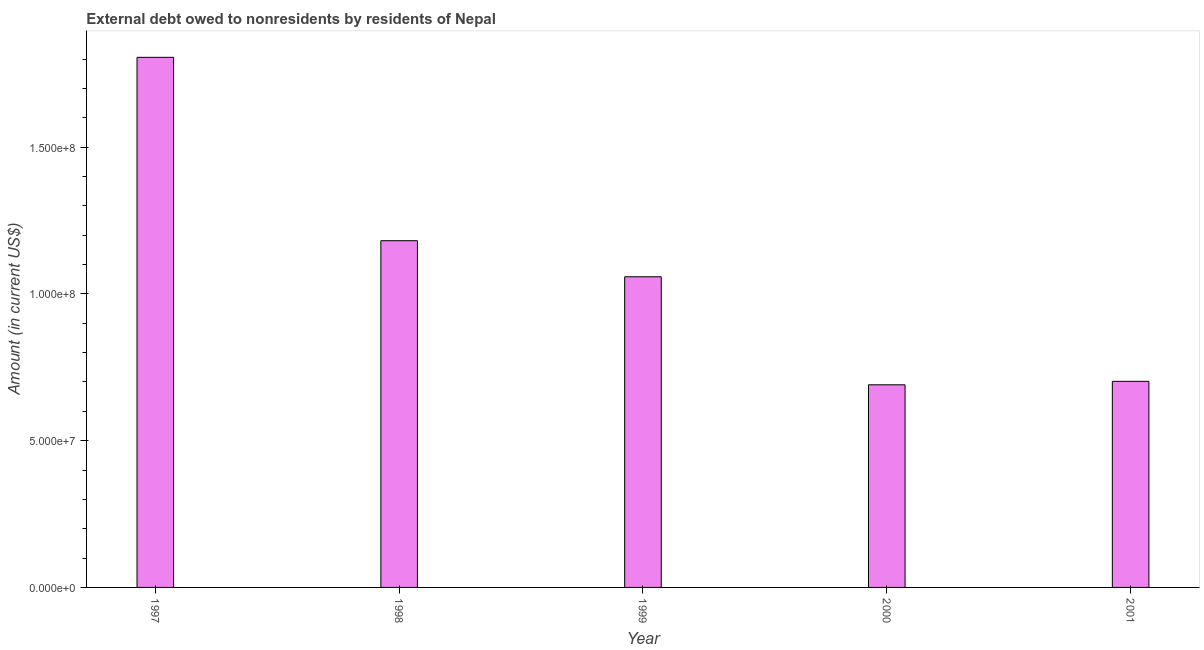What is the title of the graph?
Offer a terse response. External debt owed to nonresidents by residents of Nepal. What is the debt in 2001?
Your response must be concise. 7.02e+07. Across all years, what is the maximum debt?
Give a very brief answer. 1.81e+08. Across all years, what is the minimum debt?
Make the answer very short. 6.90e+07. What is the sum of the debt?
Give a very brief answer. 5.44e+08. What is the difference between the debt in 1997 and 2000?
Provide a succinct answer. 1.12e+08. What is the average debt per year?
Keep it short and to the point. 1.09e+08. What is the median debt?
Offer a terse response. 1.06e+08. Do a majority of the years between 1999 and 1998 (inclusive) have debt greater than 100000000 US$?
Your answer should be compact. No. What is the ratio of the debt in 2000 to that in 2001?
Your answer should be compact. 0.98. Is the debt in 1999 less than that in 2000?
Your response must be concise. No. Is the difference between the debt in 1998 and 2001 greater than the difference between any two years?
Your answer should be very brief. No. What is the difference between the highest and the second highest debt?
Your response must be concise. 6.25e+07. Is the sum of the debt in 1999 and 2001 greater than the maximum debt across all years?
Give a very brief answer. No. What is the difference between the highest and the lowest debt?
Provide a succinct answer. 1.12e+08. In how many years, is the debt greater than the average debt taken over all years?
Keep it short and to the point. 2. How many bars are there?
Your answer should be compact. 5. Are all the bars in the graph horizontal?
Give a very brief answer. No. What is the difference between two consecutive major ticks on the Y-axis?
Offer a very short reply. 5.00e+07. Are the values on the major ticks of Y-axis written in scientific E-notation?
Offer a very short reply. Yes. What is the Amount (in current US$) of 1997?
Offer a very short reply. 1.81e+08. What is the Amount (in current US$) in 1998?
Give a very brief answer. 1.18e+08. What is the Amount (in current US$) in 1999?
Keep it short and to the point. 1.06e+08. What is the Amount (in current US$) in 2000?
Ensure brevity in your answer.  6.90e+07. What is the Amount (in current US$) of 2001?
Your response must be concise. 7.02e+07. What is the difference between the Amount (in current US$) in 1997 and 1998?
Provide a succinct answer. 6.25e+07. What is the difference between the Amount (in current US$) in 1997 and 1999?
Provide a succinct answer. 7.48e+07. What is the difference between the Amount (in current US$) in 1997 and 2000?
Your response must be concise. 1.12e+08. What is the difference between the Amount (in current US$) in 1997 and 2001?
Make the answer very short. 1.10e+08. What is the difference between the Amount (in current US$) in 1998 and 1999?
Your answer should be compact. 1.23e+07. What is the difference between the Amount (in current US$) in 1998 and 2000?
Your response must be concise. 4.91e+07. What is the difference between the Amount (in current US$) in 1998 and 2001?
Make the answer very short. 4.79e+07. What is the difference between the Amount (in current US$) in 1999 and 2000?
Offer a terse response. 3.68e+07. What is the difference between the Amount (in current US$) in 1999 and 2001?
Provide a short and direct response. 3.56e+07. What is the difference between the Amount (in current US$) in 2000 and 2001?
Offer a terse response. -1.18e+06. What is the ratio of the Amount (in current US$) in 1997 to that in 1998?
Offer a terse response. 1.53. What is the ratio of the Amount (in current US$) in 1997 to that in 1999?
Offer a terse response. 1.71. What is the ratio of the Amount (in current US$) in 1997 to that in 2000?
Offer a very short reply. 2.62. What is the ratio of the Amount (in current US$) in 1997 to that in 2001?
Ensure brevity in your answer.  2.57. What is the ratio of the Amount (in current US$) in 1998 to that in 1999?
Give a very brief answer. 1.12. What is the ratio of the Amount (in current US$) in 1998 to that in 2000?
Your response must be concise. 1.71. What is the ratio of the Amount (in current US$) in 1998 to that in 2001?
Your answer should be compact. 1.68. What is the ratio of the Amount (in current US$) in 1999 to that in 2000?
Make the answer very short. 1.53. What is the ratio of the Amount (in current US$) in 1999 to that in 2001?
Give a very brief answer. 1.51. 